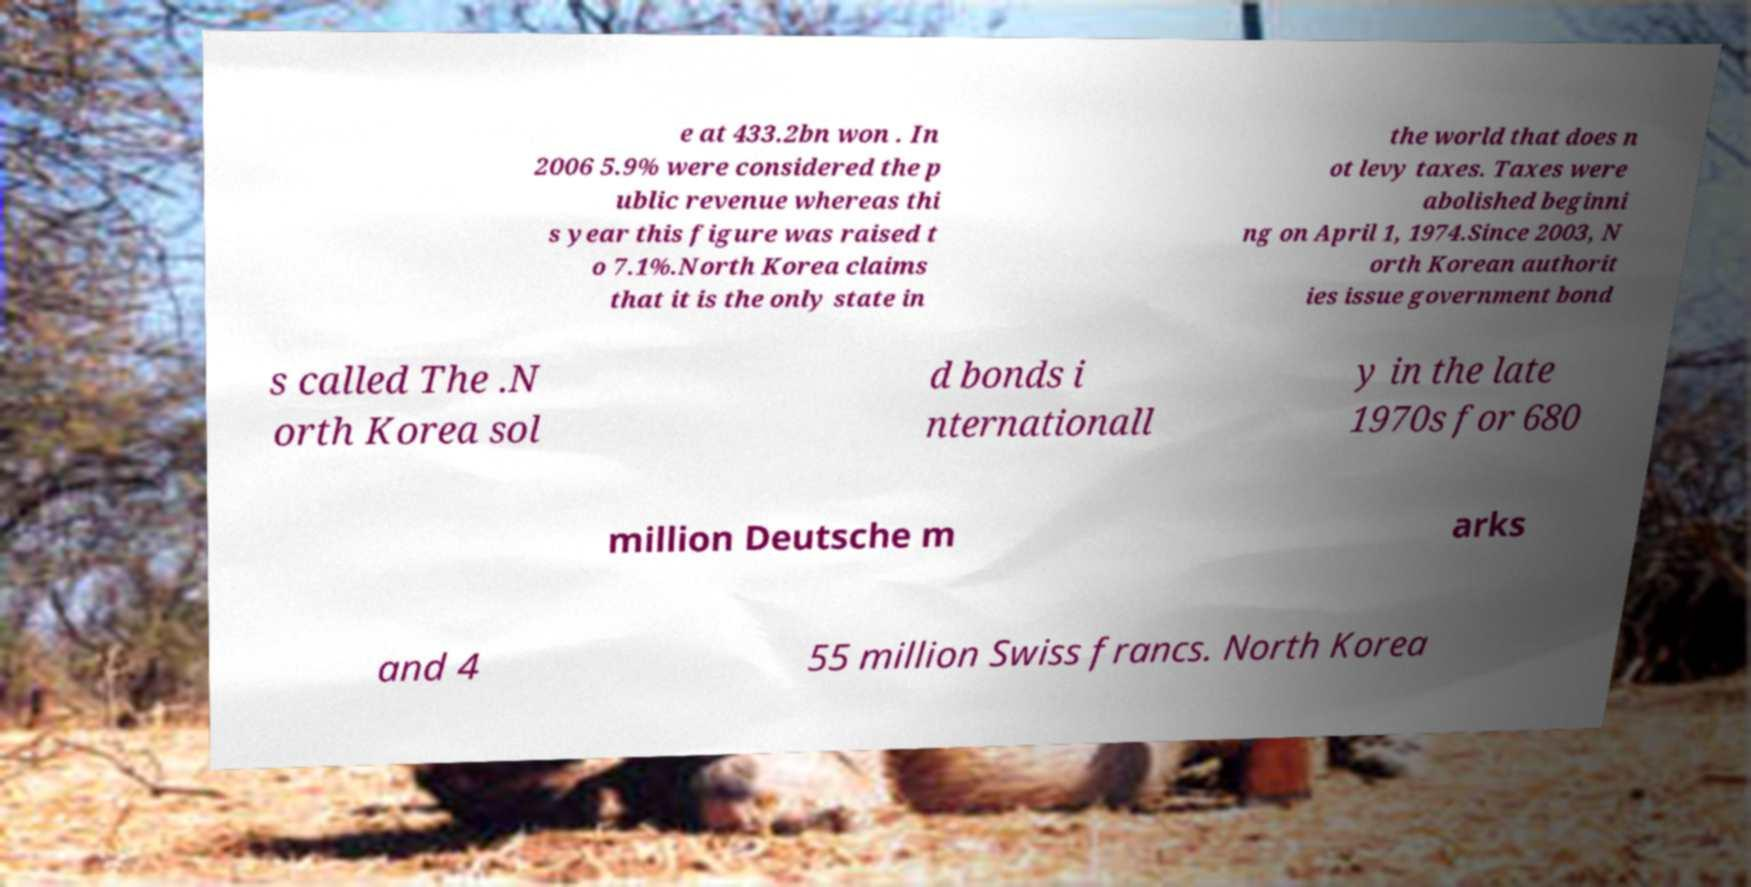Could you assist in decoding the text presented in this image and type it out clearly? e at 433.2bn won . In 2006 5.9% were considered the p ublic revenue whereas thi s year this figure was raised t o 7.1%.North Korea claims that it is the only state in the world that does n ot levy taxes. Taxes were abolished beginni ng on April 1, 1974.Since 2003, N orth Korean authorit ies issue government bond s called The .N orth Korea sol d bonds i nternationall y in the late 1970s for 680 million Deutsche m arks and 4 55 million Swiss francs. North Korea 